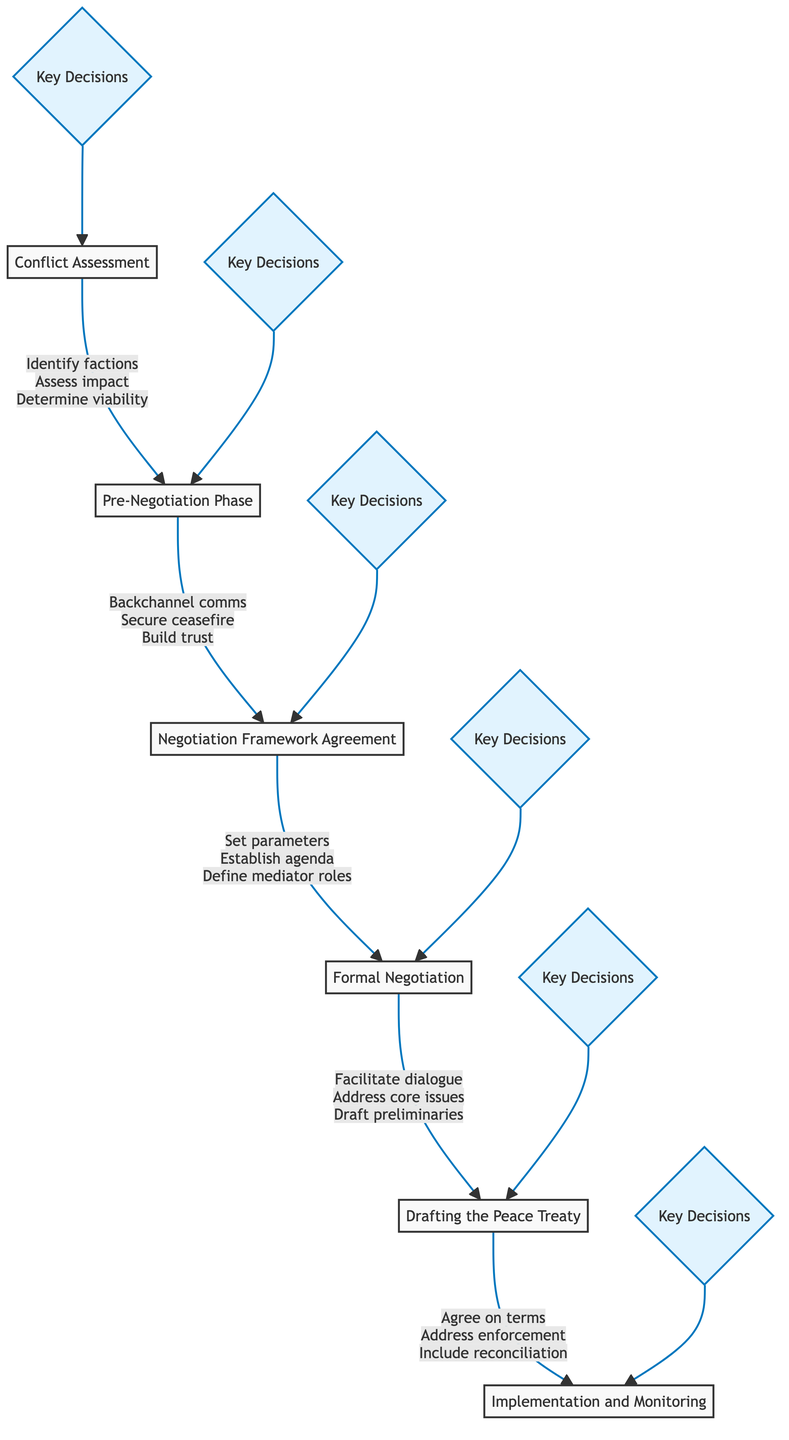What is the first step in the negotiation process? The first step is "Conflict Assessment," which involves evaluating the conflict situation and the involved parties.
Answer: Conflict Assessment How many key decision points are there in the "Drafting the Peace Treaty" step? The "Drafting the Peace Treaty" step includes three key decision points: ensure agreement, address enforcement, and include reconciliation.
Answer: Three What is the last step of the peace treaty negotiation process? The last step in the process is "Implementation and Monitoring," which focuses on executing and overseeing the peace treaty.
Answer: Implementation and Monitoring Which step involves engaging in backchannel communications? The "Pre-Negotiation Phase" is where engaging in backchannel communications occurs, aiming to prepare for formal negotiations.
Answer: Pre-Negotiation Phase How does "Formal Negotiation" relate to "Negotiation Framework Agreement"? "Formal Negotiation" follows the "Negotiation Framework Agreement," and it involves conducting official sessions based on the previously set framework.
Answer: Follows What are the three core issues addressed during "Formal Negotiation"? During "Formal Negotiation," the core issues addressed are power-sharing, disarmament, and governance.
Answer: Power-sharing, disarmament, governance What key decision occurs right after the "Conflict Assessment"? After "Conflict Assessment," the next key decision is related to engaging in the "Pre-Negotiation Phase."
Answer: Pre-Negotiation Phase What is a key decision point in the "Implementation and Monitoring" step? A key decision point in "Implementation and Monitoring" is to establish a monitoring body, like UN Peacekeeping Forces.
Answer: Establish monitoring body What does the "Drafting the Peace Treaty" step concern? The "Drafting the Peace Treaty" step concerns formulating the final peace agreement document, ensuring all necessary terms are included.
Answer: Final peace agreement document 